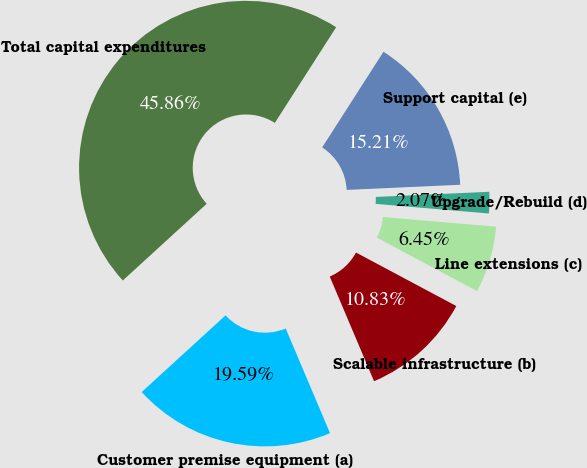Convert chart. <chart><loc_0><loc_0><loc_500><loc_500><pie_chart><fcel>Customer premise equipment (a)<fcel>Scalable infrastructure (b)<fcel>Line extensions (c)<fcel>Upgrade/Rebuild (d)<fcel>Support capital (e)<fcel>Total capital expenditures<nl><fcel>19.59%<fcel>10.83%<fcel>6.45%<fcel>2.07%<fcel>15.21%<fcel>45.87%<nl></chart> 